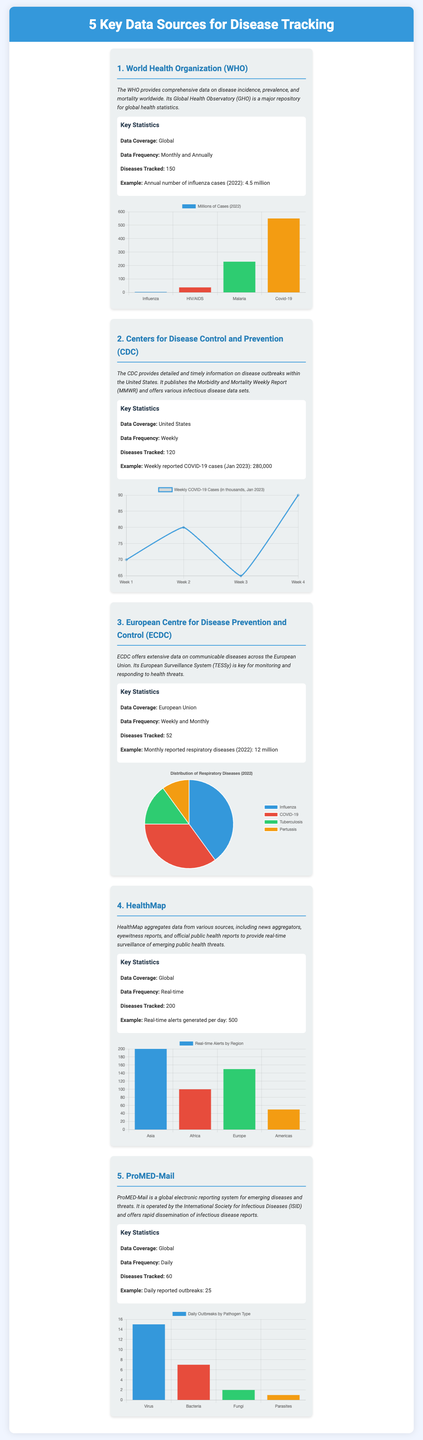What is the key data source provided by the World Health Organization? The World Health Organization provides global data on disease incidence, prevalence, and mortality.
Answer: World Health Organization How many diseases does the CDC track? The document states that the CDC tracks a specific number of diseases.
Answer: 120 What is the data frequency for the European Centre for Disease Prevention and Control? The data frequency of the European Centre for Disease Prevention and Control is mentioned in the document, showing how often data is updated.
Answer: Weekly and Monthly What is the total number of influenza cases reported by the WHO in 2022? The document gives a specific example of health statistics provided by the WHO for influenza cases in 2022.
Answer: 4.5 million How many daily reported outbreaks does ProMED-Mail track? ProMED-Mail reports a certain number of outbreaks daily, as indicated in the document.
Answer: 25 What type of chart is used to represent the distribution of respiratory diseases by ECDC? The ECDC uses a specific type of chart to illustrate the distribution of respiratory diseases, as seen in the document.
Answer: Pie What is the primary function of HealthMap according to the document? HealthMap's role is described in terms of its focus on monitoring threats through aggregation from various sources.
Answer: Real-time surveillance Which pathogen type has the least daily outbreaks reported by ProMED-Mail? The document provides a breakdown of daily outbreaks by pathogen type, indicating which had the least occurrences.
Answer: Parasites How many total diseases does HealthMap track? The immunological data and disease counts for HealthMap are specified in the document.
Answer: 200 